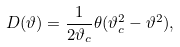<formula> <loc_0><loc_0><loc_500><loc_500>D ( \vartheta ) = \frac { 1 } { 2 \vartheta _ { c } } \theta ( \vartheta _ { c } ^ { 2 } - \vartheta ^ { 2 } ) ,</formula> 